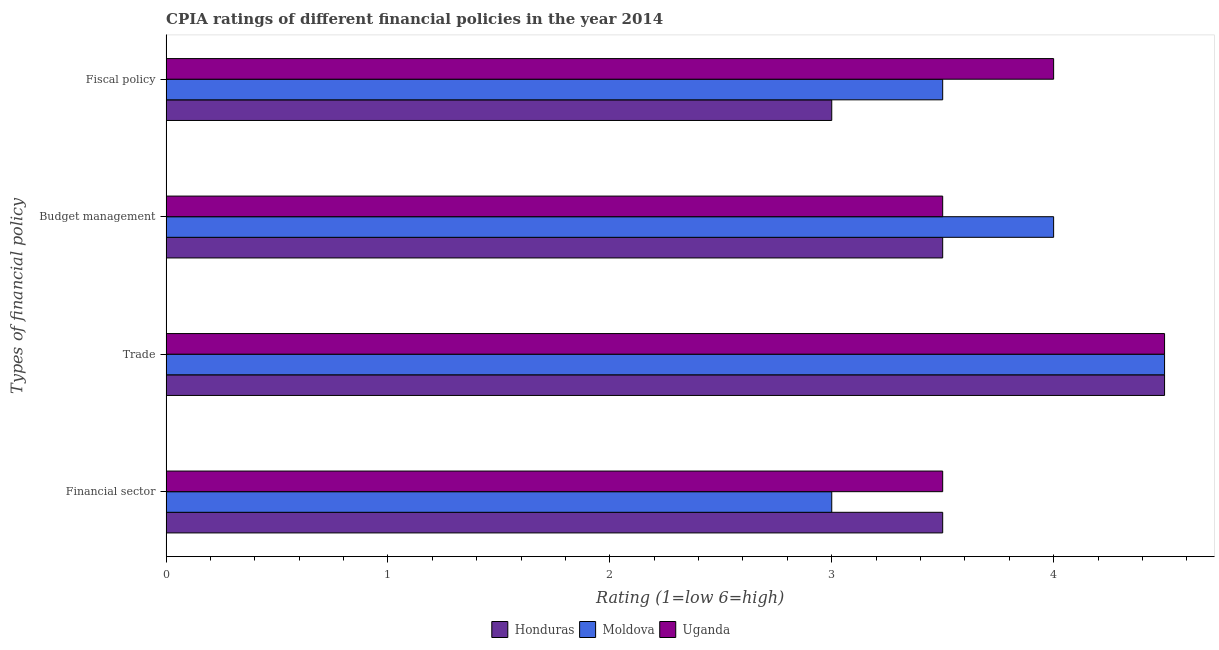Are the number of bars per tick equal to the number of legend labels?
Offer a terse response. Yes. Are the number of bars on each tick of the Y-axis equal?
Your answer should be compact. Yes. What is the label of the 3rd group of bars from the top?
Ensure brevity in your answer.  Trade. Across all countries, what is the minimum cpia rating of financial sector?
Offer a terse response. 3. In which country was the cpia rating of budget management maximum?
Give a very brief answer. Moldova. In which country was the cpia rating of fiscal policy minimum?
Offer a very short reply. Honduras. What is the total cpia rating of fiscal policy in the graph?
Your answer should be compact. 10.5. What is the difference between the cpia rating of trade in Moldova and the cpia rating of financial sector in Uganda?
Ensure brevity in your answer.  1. What is the average cpia rating of budget management per country?
Your answer should be very brief. 3.67. What is the ratio of the cpia rating of budget management in Uganda to that in Moldova?
Offer a very short reply. 0.88. Is the difference between the cpia rating of financial sector in Uganda and Honduras greater than the difference between the cpia rating of trade in Uganda and Honduras?
Give a very brief answer. No. What is the difference between the highest and the second highest cpia rating of fiscal policy?
Your answer should be very brief. 0.5. What is the difference between the highest and the lowest cpia rating of budget management?
Provide a short and direct response. 0.5. Is the sum of the cpia rating of trade in Honduras and Moldova greater than the maximum cpia rating of fiscal policy across all countries?
Make the answer very short. Yes. What does the 3rd bar from the top in Fiscal policy represents?
Offer a terse response. Honduras. What does the 2nd bar from the bottom in Budget management represents?
Your response must be concise. Moldova. Is it the case that in every country, the sum of the cpia rating of financial sector and cpia rating of trade is greater than the cpia rating of budget management?
Give a very brief answer. Yes. What is the difference between two consecutive major ticks on the X-axis?
Your answer should be very brief. 1. Are the values on the major ticks of X-axis written in scientific E-notation?
Give a very brief answer. No. Does the graph contain grids?
Offer a very short reply. No. Where does the legend appear in the graph?
Ensure brevity in your answer.  Bottom center. How are the legend labels stacked?
Ensure brevity in your answer.  Horizontal. What is the title of the graph?
Your response must be concise. CPIA ratings of different financial policies in the year 2014. Does "Kuwait" appear as one of the legend labels in the graph?
Your answer should be compact. No. What is the label or title of the X-axis?
Your response must be concise. Rating (1=low 6=high). What is the label or title of the Y-axis?
Give a very brief answer. Types of financial policy. What is the Rating (1=low 6=high) of Moldova in Financial sector?
Provide a succinct answer. 3. What is the Rating (1=low 6=high) of Uganda in Trade?
Ensure brevity in your answer.  4.5. What is the Rating (1=low 6=high) of Uganda in Budget management?
Your answer should be compact. 3.5. Across all Types of financial policy, what is the maximum Rating (1=low 6=high) of Moldova?
Your answer should be very brief. 4.5. Across all Types of financial policy, what is the minimum Rating (1=low 6=high) of Moldova?
Your answer should be compact. 3. What is the total Rating (1=low 6=high) of Honduras in the graph?
Offer a terse response. 14.5. What is the total Rating (1=low 6=high) of Moldova in the graph?
Keep it short and to the point. 15. What is the total Rating (1=low 6=high) of Uganda in the graph?
Your answer should be very brief. 15.5. What is the difference between the Rating (1=low 6=high) of Honduras in Financial sector and that in Budget management?
Keep it short and to the point. 0. What is the difference between the Rating (1=low 6=high) of Moldova in Financial sector and that in Budget management?
Ensure brevity in your answer.  -1. What is the difference between the Rating (1=low 6=high) in Uganda in Financial sector and that in Fiscal policy?
Offer a terse response. -0.5. What is the difference between the Rating (1=low 6=high) in Honduras in Trade and that in Budget management?
Your answer should be very brief. 1. What is the difference between the Rating (1=low 6=high) in Uganda in Trade and that in Budget management?
Provide a succinct answer. 1. What is the difference between the Rating (1=low 6=high) in Uganda in Trade and that in Fiscal policy?
Make the answer very short. 0.5. What is the difference between the Rating (1=low 6=high) of Moldova in Budget management and that in Fiscal policy?
Your answer should be very brief. 0.5. What is the difference between the Rating (1=low 6=high) of Uganda in Budget management and that in Fiscal policy?
Offer a very short reply. -0.5. What is the difference between the Rating (1=low 6=high) in Honduras in Financial sector and the Rating (1=low 6=high) in Moldova in Trade?
Keep it short and to the point. -1. What is the difference between the Rating (1=low 6=high) of Moldova in Financial sector and the Rating (1=low 6=high) of Uganda in Budget management?
Provide a short and direct response. -0.5. What is the difference between the Rating (1=low 6=high) of Honduras in Financial sector and the Rating (1=low 6=high) of Moldova in Fiscal policy?
Ensure brevity in your answer.  0. What is the difference between the Rating (1=low 6=high) of Moldova in Trade and the Rating (1=low 6=high) of Uganda in Budget management?
Offer a very short reply. 1. What is the difference between the Rating (1=low 6=high) of Moldova in Trade and the Rating (1=low 6=high) of Uganda in Fiscal policy?
Offer a very short reply. 0.5. What is the difference between the Rating (1=low 6=high) in Honduras in Budget management and the Rating (1=low 6=high) in Uganda in Fiscal policy?
Provide a short and direct response. -0.5. What is the average Rating (1=low 6=high) in Honduras per Types of financial policy?
Your answer should be very brief. 3.62. What is the average Rating (1=low 6=high) in Moldova per Types of financial policy?
Give a very brief answer. 3.75. What is the average Rating (1=low 6=high) of Uganda per Types of financial policy?
Offer a very short reply. 3.88. What is the difference between the Rating (1=low 6=high) of Honduras and Rating (1=low 6=high) of Moldova in Financial sector?
Provide a short and direct response. 0.5. What is the difference between the Rating (1=low 6=high) in Honduras and Rating (1=low 6=high) in Uganda in Financial sector?
Give a very brief answer. 0. What is the difference between the Rating (1=low 6=high) in Honduras and Rating (1=low 6=high) in Uganda in Trade?
Provide a short and direct response. 0. What is the difference between the Rating (1=low 6=high) in Moldova and Rating (1=low 6=high) in Uganda in Budget management?
Make the answer very short. 0.5. What is the difference between the Rating (1=low 6=high) in Honduras and Rating (1=low 6=high) in Moldova in Fiscal policy?
Your answer should be very brief. -0.5. What is the difference between the Rating (1=low 6=high) of Moldova and Rating (1=low 6=high) of Uganda in Fiscal policy?
Offer a terse response. -0.5. What is the ratio of the Rating (1=low 6=high) of Honduras in Financial sector to that in Trade?
Ensure brevity in your answer.  0.78. What is the ratio of the Rating (1=low 6=high) of Moldova in Financial sector to that in Trade?
Make the answer very short. 0.67. What is the ratio of the Rating (1=low 6=high) in Uganda in Financial sector to that in Trade?
Provide a succinct answer. 0.78. What is the ratio of the Rating (1=low 6=high) in Honduras in Financial sector to that in Budget management?
Offer a very short reply. 1. What is the ratio of the Rating (1=low 6=high) in Moldova in Financial sector to that in Budget management?
Your answer should be very brief. 0.75. What is the ratio of the Rating (1=low 6=high) in Moldova in Financial sector to that in Fiscal policy?
Your response must be concise. 0.86. What is the ratio of the Rating (1=low 6=high) of Uganda in Financial sector to that in Fiscal policy?
Keep it short and to the point. 0.88. What is the ratio of the Rating (1=low 6=high) of Uganda in Trade to that in Budget management?
Give a very brief answer. 1.29. What is the ratio of the Rating (1=low 6=high) of Uganda in Trade to that in Fiscal policy?
Offer a terse response. 1.12. What is the ratio of the Rating (1=low 6=high) in Honduras in Budget management to that in Fiscal policy?
Provide a short and direct response. 1.17. What is the ratio of the Rating (1=low 6=high) of Uganda in Budget management to that in Fiscal policy?
Offer a very short reply. 0.88. What is the difference between the highest and the second highest Rating (1=low 6=high) in Honduras?
Make the answer very short. 1. What is the difference between the highest and the second highest Rating (1=low 6=high) of Moldova?
Ensure brevity in your answer.  0.5. What is the difference between the highest and the lowest Rating (1=low 6=high) in Honduras?
Give a very brief answer. 1.5. What is the difference between the highest and the lowest Rating (1=low 6=high) of Uganda?
Keep it short and to the point. 1. 